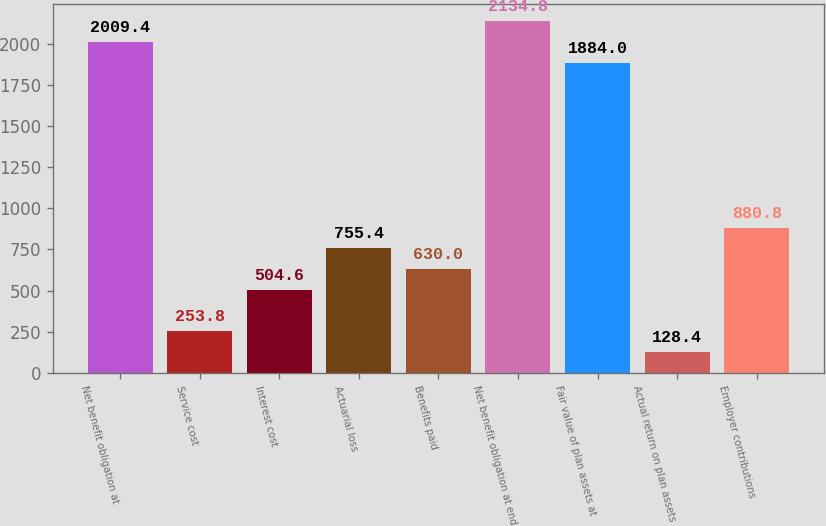Convert chart to OTSL. <chart><loc_0><loc_0><loc_500><loc_500><bar_chart><fcel>Net benefit obligation at<fcel>Service cost<fcel>Interest cost<fcel>Actuarial loss<fcel>Benefits paid<fcel>Net benefit obligation at end<fcel>Fair value of plan assets at<fcel>Actual return on plan assets<fcel>Employer contributions<nl><fcel>2009.4<fcel>253.8<fcel>504.6<fcel>755.4<fcel>630<fcel>2134.8<fcel>1884<fcel>128.4<fcel>880.8<nl></chart> 